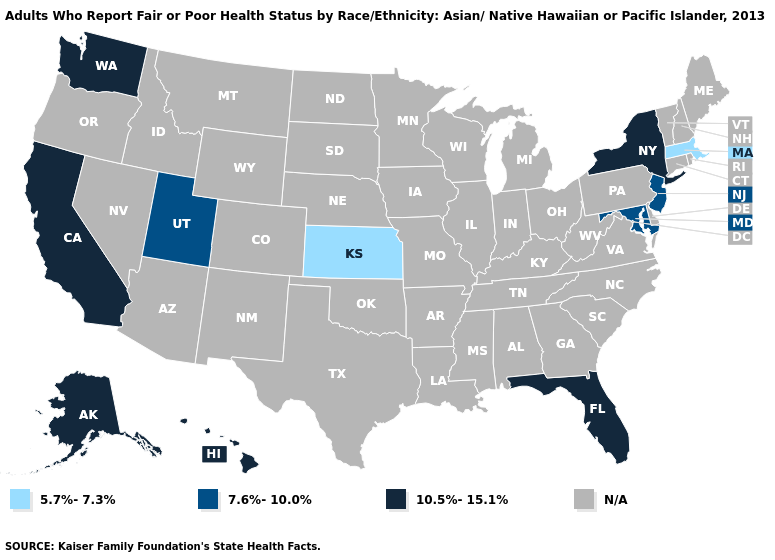What is the value of Vermont?
Keep it brief. N/A. How many symbols are there in the legend?
Quick response, please. 4. Is the legend a continuous bar?
Give a very brief answer. No. Which states have the lowest value in the West?
Be succinct. Utah. Name the states that have a value in the range N/A?
Short answer required. Alabama, Arizona, Arkansas, Colorado, Connecticut, Delaware, Georgia, Idaho, Illinois, Indiana, Iowa, Kentucky, Louisiana, Maine, Michigan, Minnesota, Mississippi, Missouri, Montana, Nebraska, Nevada, New Hampshire, New Mexico, North Carolina, North Dakota, Ohio, Oklahoma, Oregon, Pennsylvania, Rhode Island, South Carolina, South Dakota, Tennessee, Texas, Vermont, Virginia, West Virginia, Wisconsin, Wyoming. Does the first symbol in the legend represent the smallest category?
Write a very short answer. Yes. Is the legend a continuous bar?
Be succinct. No. Name the states that have a value in the range 7.6%-10.0%?
Answer briefly. Maryland, New Jersey, Utah. Among the states that border Vermont , which have the lowest value?
Be succinct. Massachusetts. Does the map have missing data?
Write a very short answer. Yes. What is the value of Tennessee?
Write a very short answer. N/A. What is the value of Massachusetts?
Give a very brief answer. 5.7%-7.3%. Name the states that have a value in the range N/A?
Keep it brief. Alabama, Arizona, Arkansas, Colorado, Connecticut, Delaware, Georgia, Idaho, Illinois, Indiana, Iowa, Kentucky, Louisiana, Maine, Michigan, Minnesota, Mississippi, Missouri, Montana, Nebraska, Nevada, New Hampshire, New Mexico, North Carolina, North Dakota, Ohio, Oklahoma, Oregon, Pennsylvania, Rhode Island, South Carolina, South Dakota, Tennessee, Texas, Vermont, Virginia, West Virginia, Wisconsin, Wyoming. 